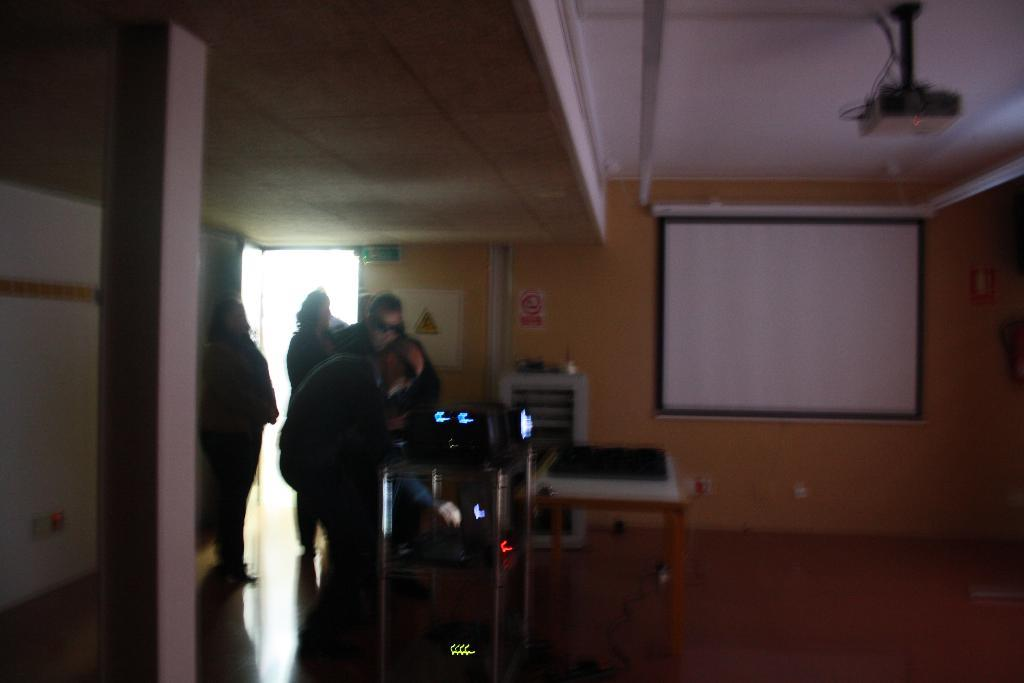How many people are in the image? There is a group of people in the image, but the exact number cannot be determined from the provided facts. What device is used to display images in the image? There is a projector in the image. What is used to display the projected images? There is a projector screen in the image. Can you see a ghost on the projector screen in the image? There is no mention of a ghost in the image, so it cannot be determined if one is present. 